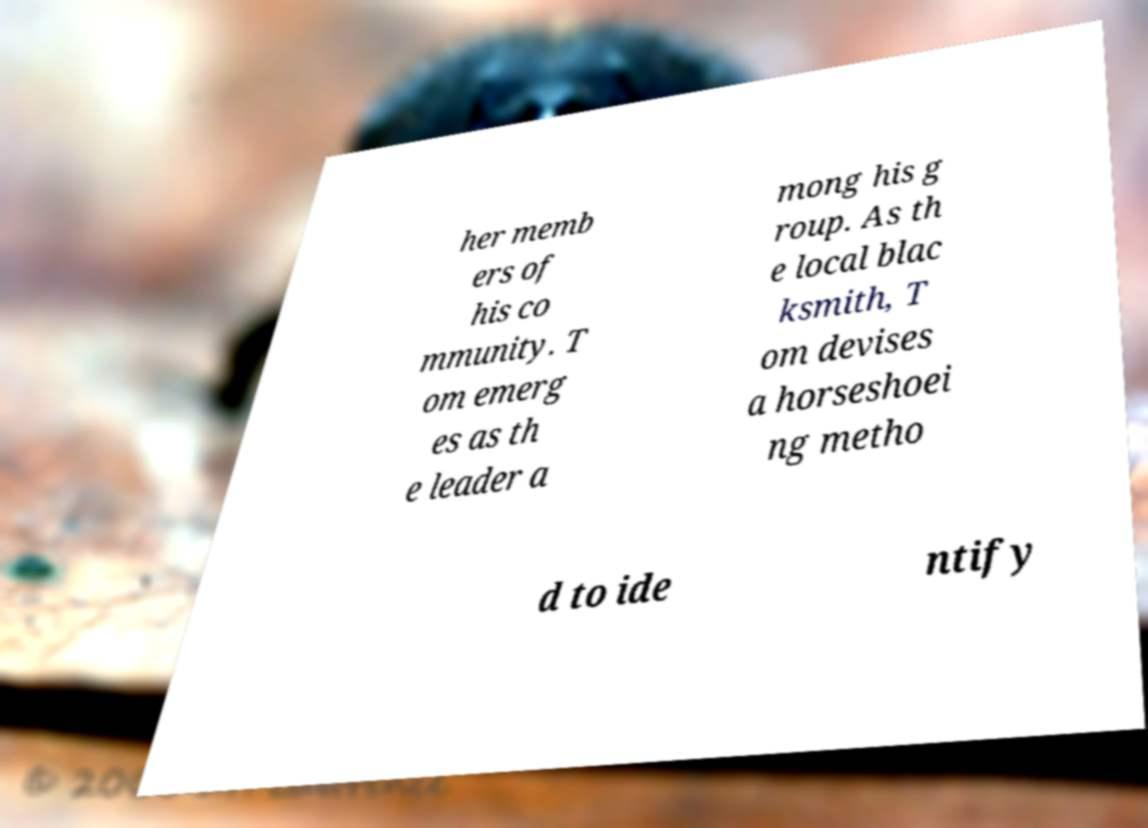I need the written content from this picture converted into text. Can you do that? her memb ers of his co mmunity. T om emerg es as th e leader a mong his g roup. As th e local blac ksmith, T om devises a horseshoei ng metho d to ide ntify 